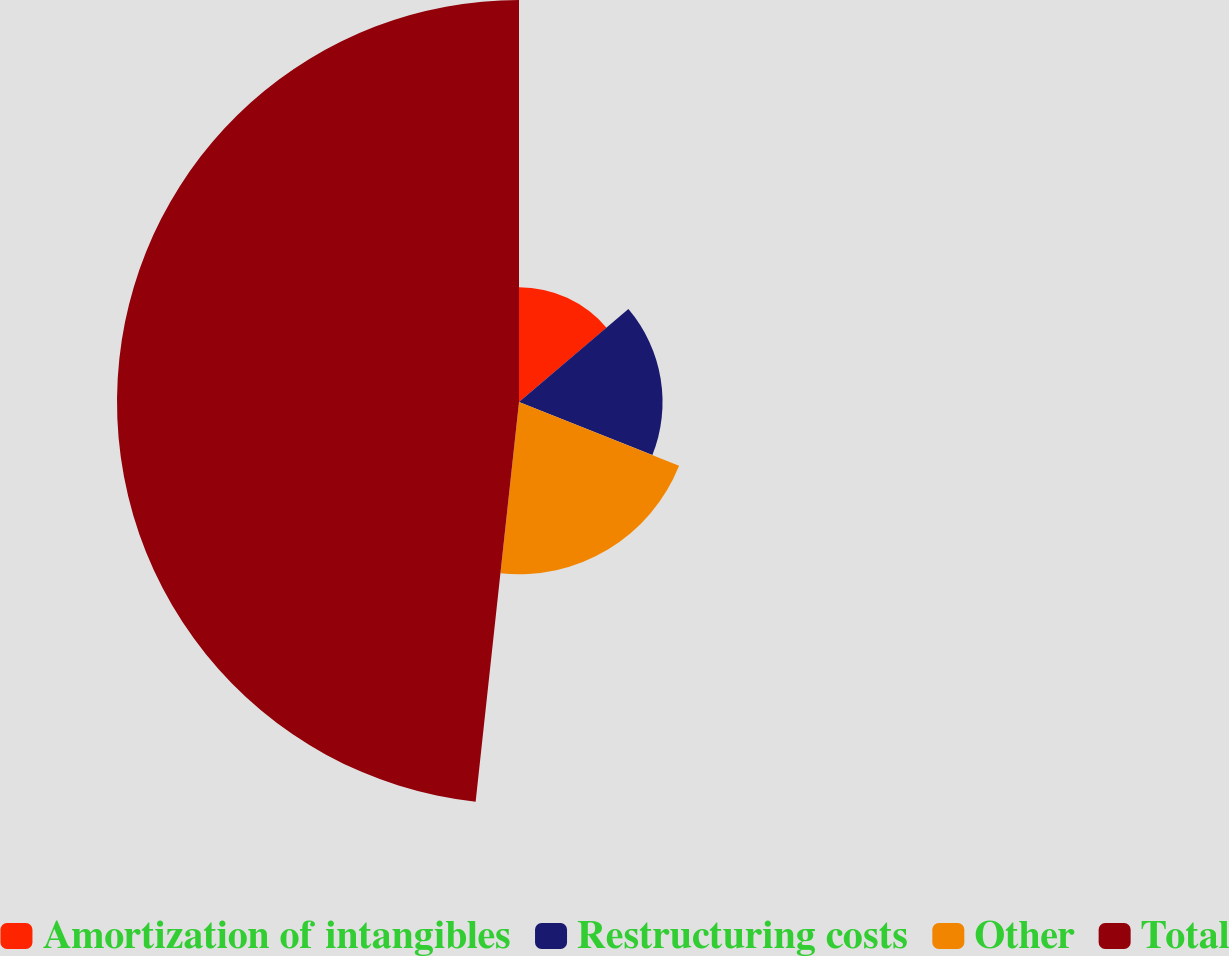Convert chart. <chart><loc_0><loc_0><loc_500><loc_500><pie_chart><fcel>Amortization of intangibles<fcel>Restructuring costs<fcel>Other<fcel>Total<nl><fcel>13.79%<fcel>17.24%<fcel>20.69%<fcel>48.28%<nl></chart> 